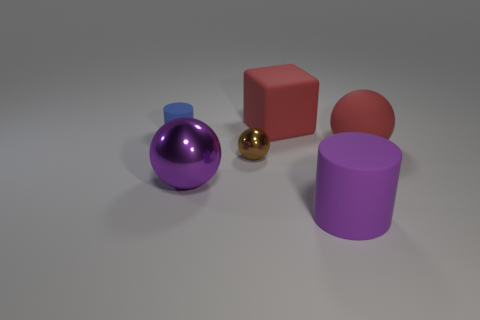Are any tiny purple rubber blocks visible?
Your answer should be very brief. No. What number of things are either cylinders that are in front of the blue rubber object or large red rubber blocks?
Your answer should be very brief. 2. There is a object that is the same size as the blue cylinder; what is it made of?
Provide a succinct answer. Metal. There is a cylinder in front of the sphere to the right of the small ball; what is its color?
Offer a very short reply. Purple. There is a blue cylinder; how many big matte spheres are to the right of it?
Make the answer very short. 1. What is the color of the matte cube?
Provide a succinct answer. Red. What number of large objects are either shiny things or matte objects?
Keep it short and to the point. 4. There is a cylinder on the left side of the large red cube; does it have the same color as the tiny thing that is in front of the big red rubber ball?
Offer a terse response. No. What number of other things are the same color as the big block?
Your answer should be compact. 1. The large matte object that is in front of the tiny brown metal thing has what shape?
Your answer should be compact. Cylinder. 